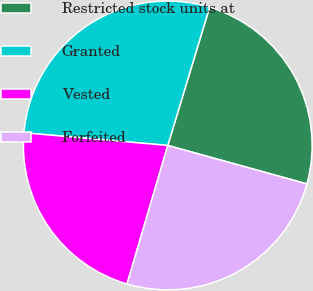<chart> <loc_0><loc_0><loc_500><loc_500><pie_chart><fcel>Restricted stock units at<fcel>Granted<fcel>Vested<fcel>Forfeited<nl><fcel>24.62%<fcel>28.28%<fcel>21.85%<fcel>25.26%<nl></chart> 